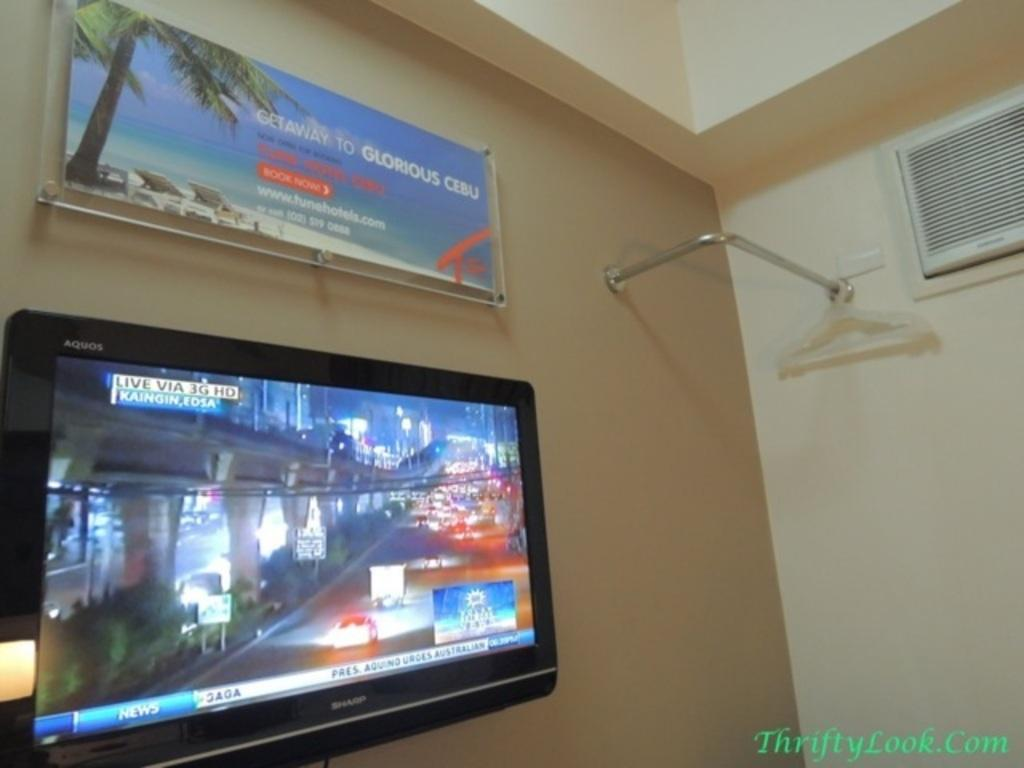<image>
Present a compact description of the photo's key features. A poster with the text 'Gateway to Glorious Cebu' hangs on the wall. 